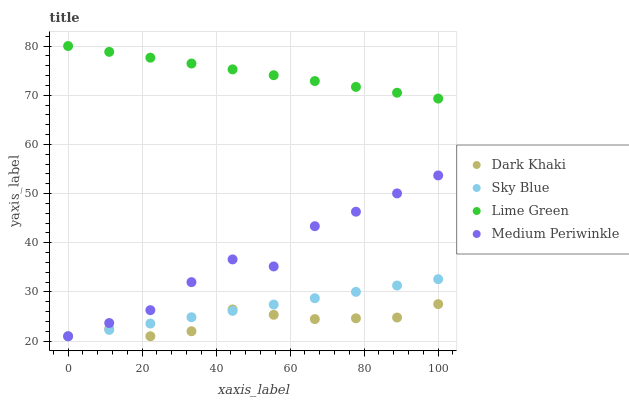Does Dark Khaki have the minimum area under the curve?
Answer yes or no. Yes. Does Lime Green have the maximum area under the curve?
Answer yes or no. Yes. Does Sky Blue have the minimum area under the curve?
Answer yes or no. No. Does Sky Blue have the maximum area under the curve?
Answer yes or no. No. Is Sky Blue the smoothest?
Answer yes or no. Yes. Is Medium Periwinkle the roughest?
Answer yes or no. Yes. Is Lime Green the smoothest?
Answer yes or no. No. Is Lime Green the roughest?
Answer yes or no. No. Does Dark Khaki have the lowest value?
Answer yes or no. Yes. Does Lime Green have the lowest value?
Answer yes or no. No. Does Lime Green have the highest value?
Answer yes or no. Yes. Does Sky Blue have the highest value?
Answer yes or no. No. Is Sky Blue less than Lime Green?
Answer yes or no. Yes. Is Lime Green greater than Medium Periwinkle?
Answer yes or no. Yes. Does Sky Blue intersect Medium Periwinkle?
Answer yes or no. Yes. Is Sky Blue less than Medium Periwinkle?
Answer yes or no. No. Is Sky Blue greater than Medium Periwinkle?
Answer yes or no. No. Does Sky Blue intersect Lime Green?
Answer yes or no. No. 